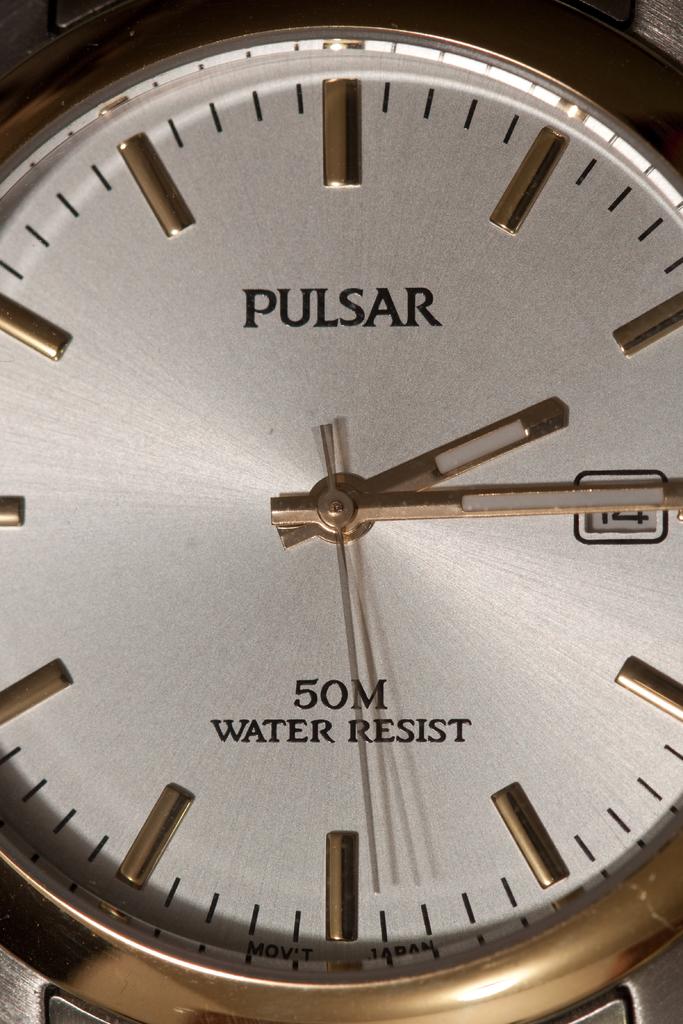What is the brand of the watch?
Provide a succinct answer. Pulsar. Is this watch water resistant?
Your answer should be very brief. Yes. 